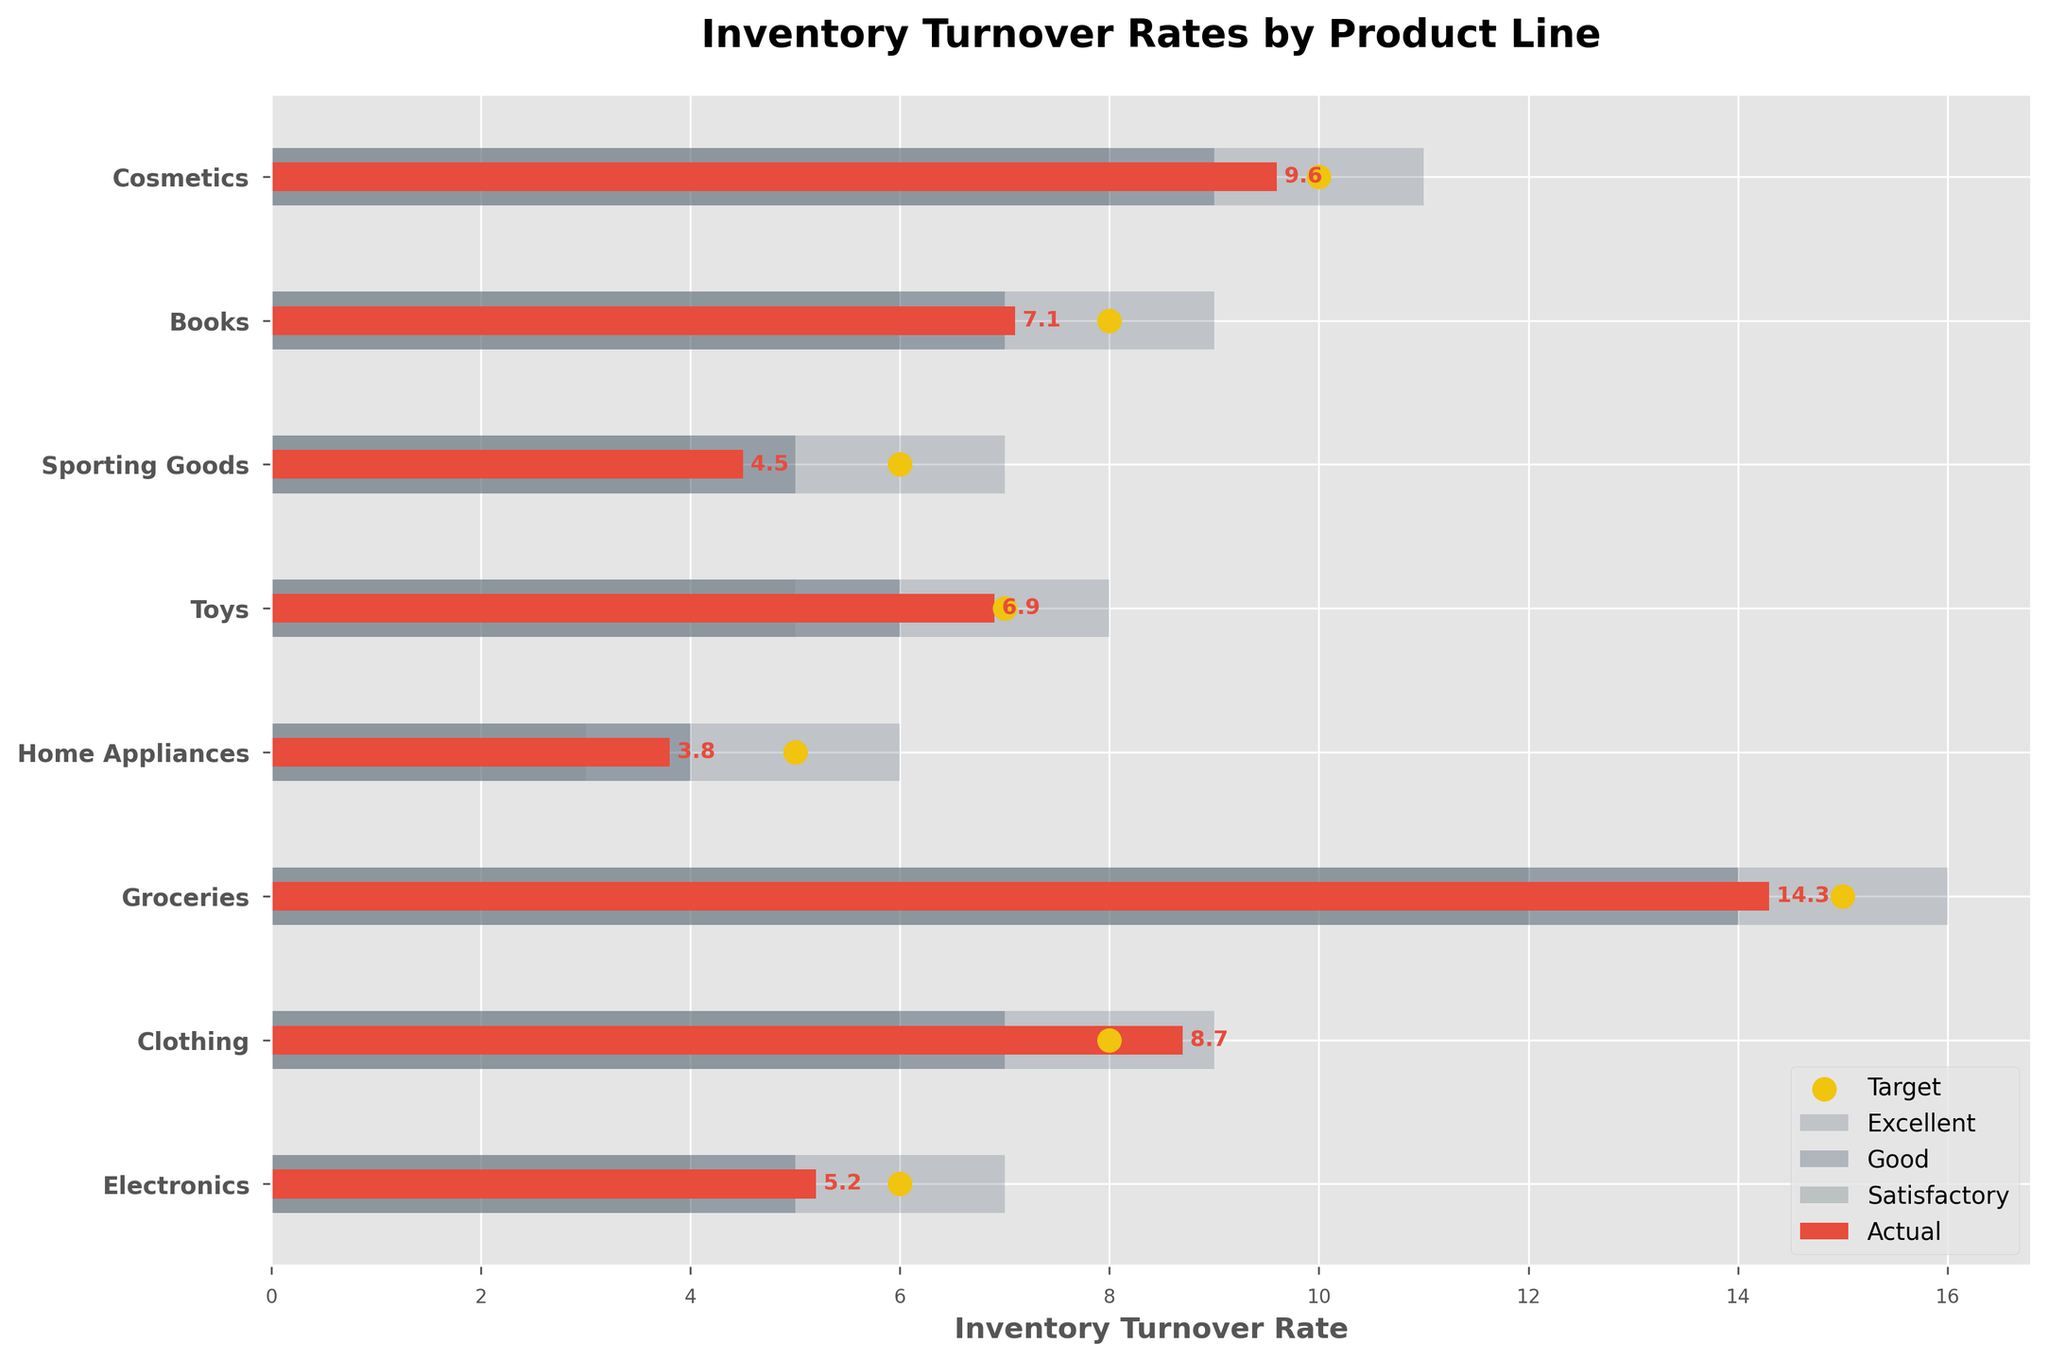What is the title of the figure? The title is typically located at the top of the chart. In this case, it states 'Inventory Turnover Rates by Product Line'.
Answer: Inventory Turnover Rates by Product Line Which product line has the highest actual inventory turnover rate? By looking at the bars that represent the actual turnover, the longest bar indicates the highest rate. 'Groceries' has the longest bar representing an actual turnover of 14.3.
Answer: Groceries What color represents 'Excellent' inventory turnover in the chart? The 'Excellent' category is represented by the background bar color furthest to the right and shaded in the darkest tone. Identifying this visually, it is shown in very dark grey.
Answer: Dark grey How many products have an actual turnover rate above their target turnover rate? Compare the length of red bars (actual turnover) to the location of the yellow scatter points (target turnover) for each product. 'Clothing' and 'Groceries' have their actual turnover bars extending beyond their target turnover points.
Answer: 2 Which product lines have an actual turnover rate falling in the 'Poor' category? The 'Poor' category is the section between 0 and the first threshold. We identify the actual turnover bars in red that fall into this range. None of the product lines have bars situated in this section.
Answer: None For which product line is the actual turnover rate closest to its target turnover rate? Observe the proximity of the red bars (actual turnovers) to the yellow scatter points (target turnovers). 'Toys' where the actual turnover is 6.9 and the target is 7, showing the closest alignment.
Answer: Toys How many products have a satisfactory actual inventory turnover rate? Turnover rates that fall into the section between 'Satisfactory' range boundaries should be considered. Review the red bars that fall within this segment. 'Electronics', 'Home Appliances', and 'Sporting Goods' fall into this range.
Answer: 3 Compare the actual turnover rate of 'Books' and 'Toys'. Which is higher? Review the red bar lengths for 'Books' and 'Toys'. 'Books' has an actual turnover rate of 7.1 while 'Toys' has 6.9 indicating that 'Books' has a higher rate.
Answer: Books Which product line exceeded the 'Excellent' target turnover rate? Actual turnover bars that reach or surpass the 'Excellent' category range should be identified. The 'Groceries' red bar reaches beyond the threshold set for 'Excellent'.
Answer: Groceries Calculate the difference between the target and actual turnover rate for 'Cosmetics'. Subtract the actual turnover (9.6) from the target turnover (10) for 'Cosmetics'. Thus, 10 - 9.6 equals a difference of 0.4.
Answer: 0.4 